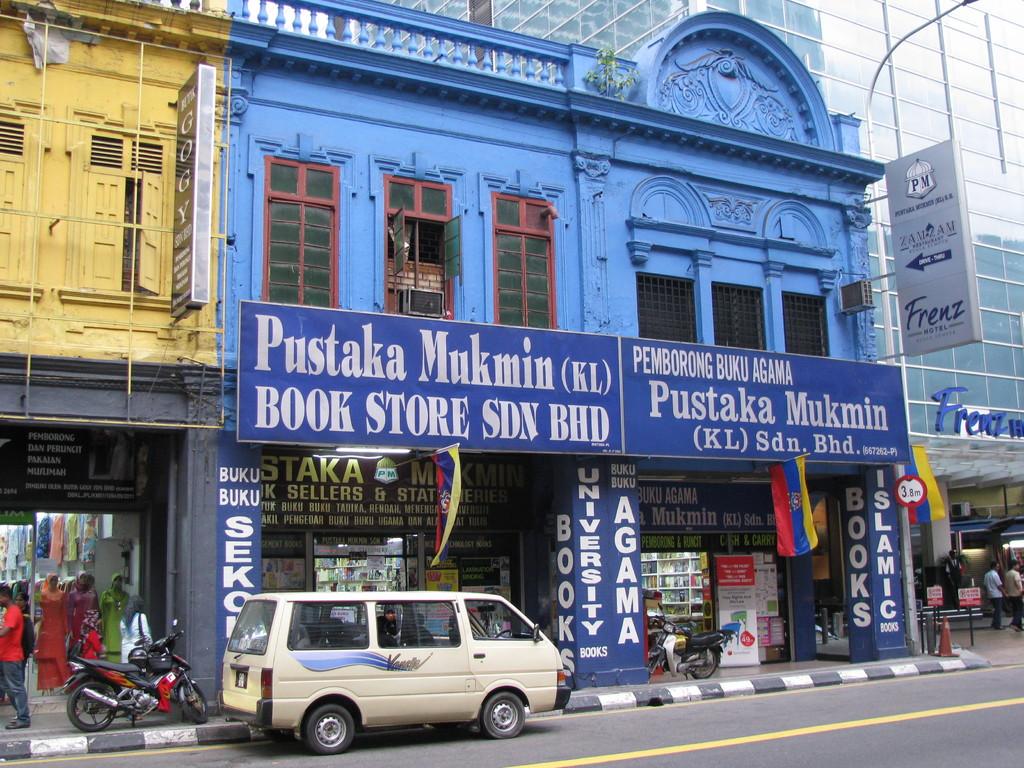What is the name of this book store?
Keep it short and to the point. Pustaka mukmin. What kind of books are shown on the right pillar?
Your answer should be very brief. Islamic. 